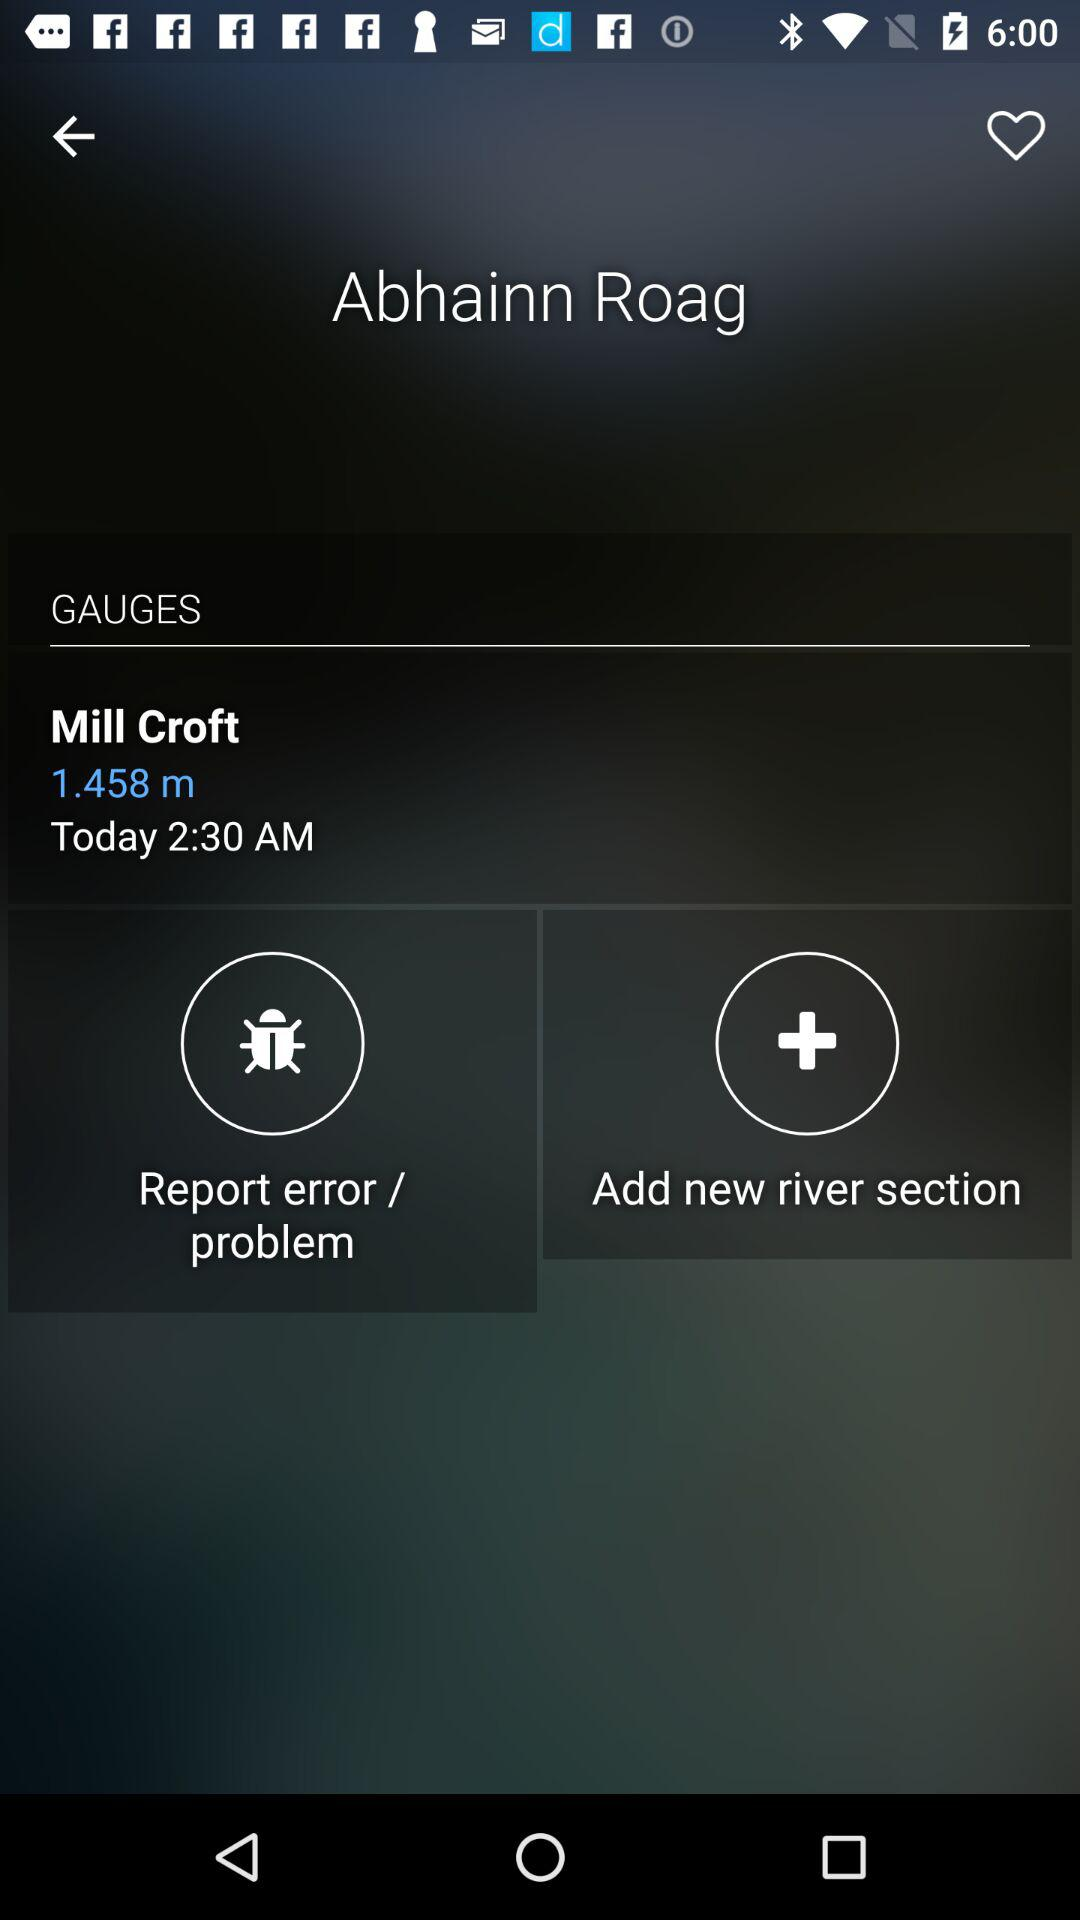What is the time? The time is 2:30 AM. 